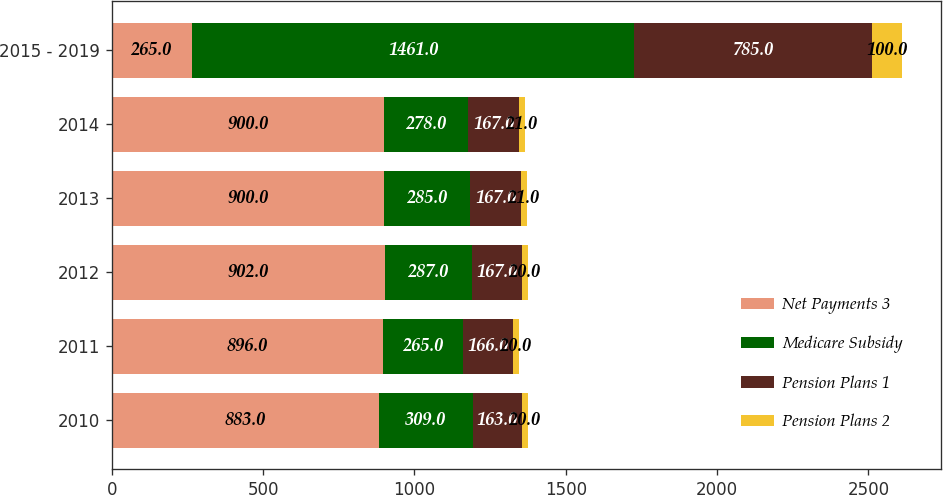Convert chart to OTSL. <chart><loc_0><loc_0><loc_500><loc_500><stacked_bar_chart><ecel><fcel>2010<fcel>2011<fcel>2012<fcel>2013<fcel>2014<fcel>2015 - 2019<nl><fcel>Net Payments 3<fcel>883<fcel>896<fcel>902<fcel>900<fcel>900<fcel>265<nl><fcel>Medicare Subsidy<fcel>309<fcel>265<fcel>287<fcel>285<fcel>278<fcel>1461<nl><fcel>Pension Plans 1<fcel>163<fcel>166<fcel>167<fcel>167<fcel>167<fcel>785<nl><fcel>Pension Plans 2<fcel>20<fcel>20<fcel>20<fcel>21<fcel>21<fcel>100<nl></chart> 